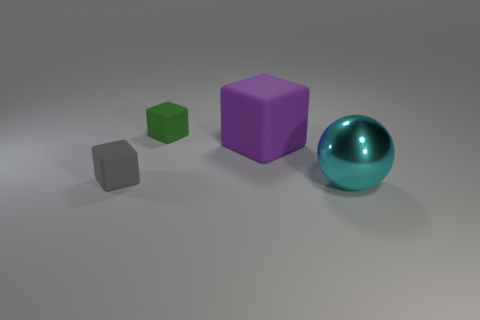Subtract all green matte blocks. How many blocks are left? 2 Add 1 metallic things. How many objects exist? 5 Subtract all blocks. How many objects are left? 1 Subtract all small matte cubes. Subtract all tiny rubber objects. How many objects are left? 0 Add 1 gray objects. How many gray objects are left? 2 Add 1 red matte cylinders. How many red matte cylinders exist? 1 Subtract 0 red cylinders. How many objects are left? 4 